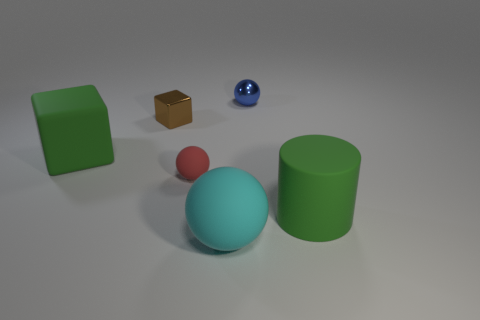Does the tiny brown object have the same shape as the tiny blue object?
Give a very brief answer. No. Is there a large matte thing that is to the right of the tiny metal object that is to the left of the cyan rubber object?
Give a very brief answer. Yes. Is the number of large green objects that are right of the small red ball the same as the number of large green things?
Make the answer very short. No. What number of other objects are the same size as the blue thing?
Offer a very short reply. 2. Does the sphere behind the red rubber thing have the same material as the big green object that is in front of the red rubber thing?
Keep it short and to the point. No. There is a green matte thing to the left of the thing that is on the right side of the blue object; what size is it?
Ensure brevity in your answer.  Large. Is there a rubber ball of the same color as the small metal block?
Offer a very short reply. No. There is a tiny ball behind the red matte object; is its color the same as the large matte thing to the right of the large rubber sphere?
Give a very brief answer. No. What is the shape of the small red object?
Offer a terse response. Sphere. There is a tiny brown object; what number of big cylinders are behind it?
Ensure brevity in your answer.  0. 